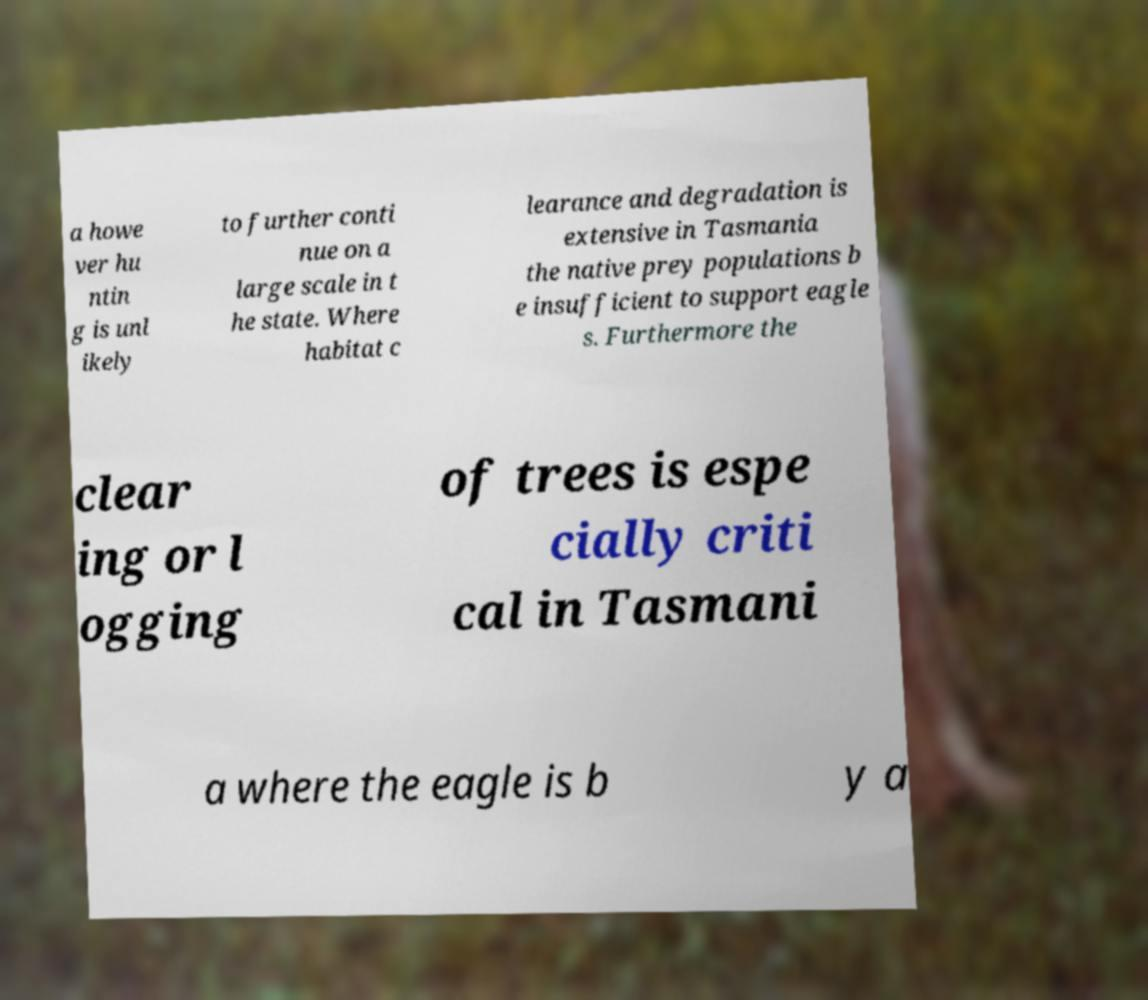Could you assist in decoding the text presented in this image and type it out clearly? a howe ver hu ntin g is unl ikely to further conti nue on a large scale in t he state. Where habitat c learance and degradation is extensive in Tasmania the native prey populations b e insufficient to support eagle s. Furthermore the clear ing or l ogging of trees is espe cially criti cal in Tasmani a where the eagle is b y a 